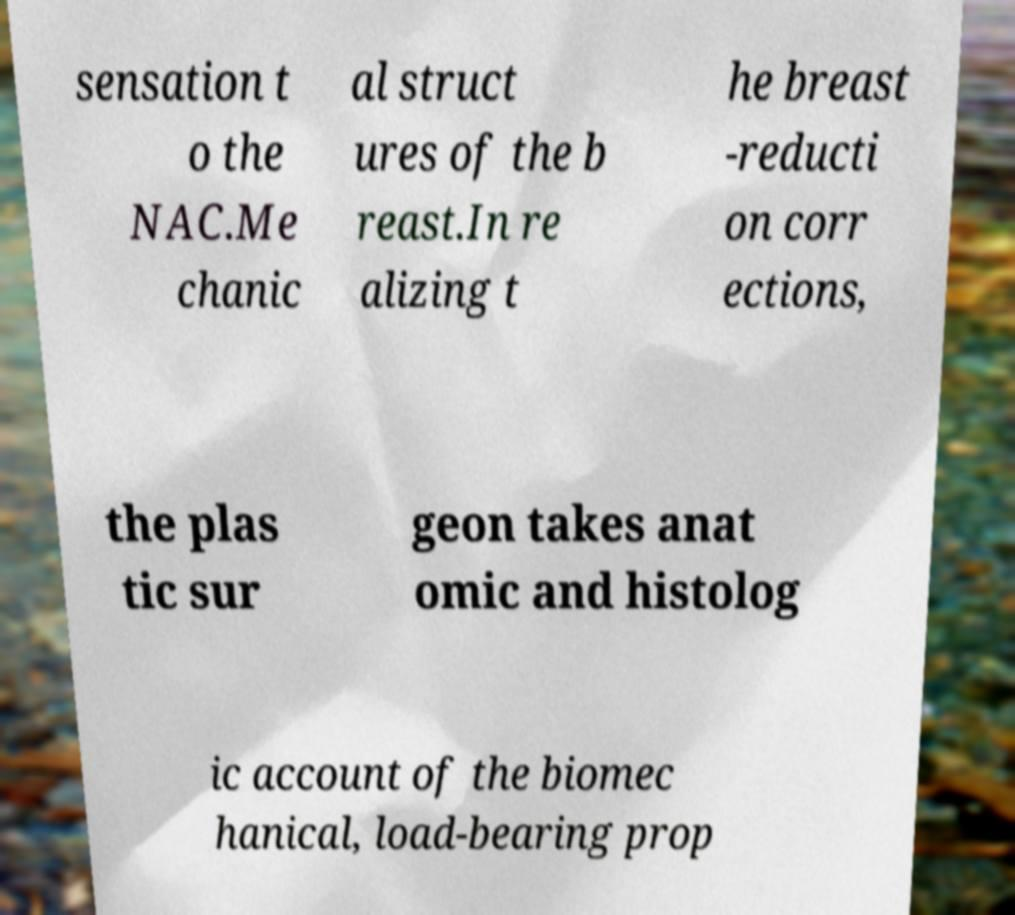Can you read and provide the text displayed in the image?This photo seems to have some interesting text. Can you extract and type it out for me? sensation t o the NAC.Me chanic al struct ures of the b reast.In re alizing t he breast -reducti on corr ections, the plas tic sur geon takes anat omic and histolog ic account of the biomec hanical, load-bearing prop 